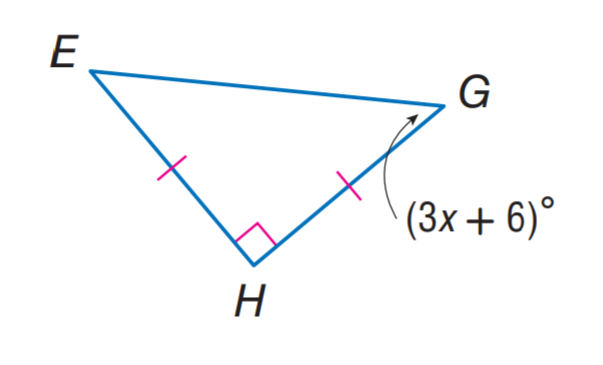Question: Find x.
Choices:
A. 3
B. 6
C. 13
D. 19
Answer with the letter. Answer: C 